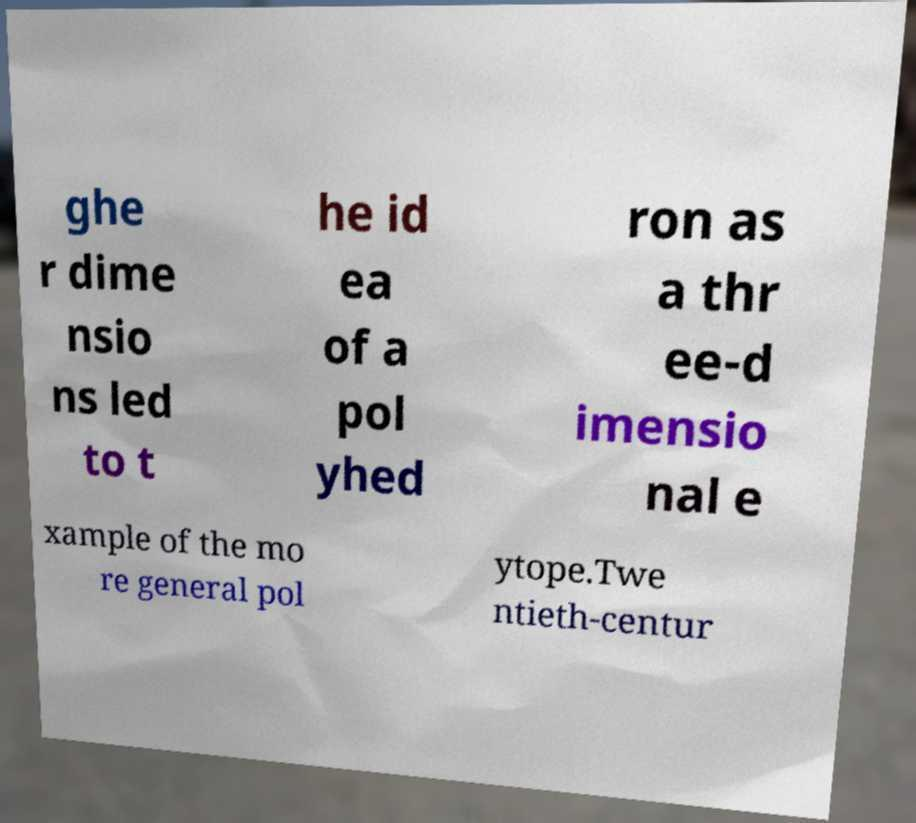Can you read and provide the text displayed in the image?This photo seems to have some interesting text. Can you extract and type it out for me? ghe r dime nsio ns led to t he id ea of a pol yhed ron as a thr ee-d imensio nal e xample of the mo re general pol ytope.Twe ntieth-centur 